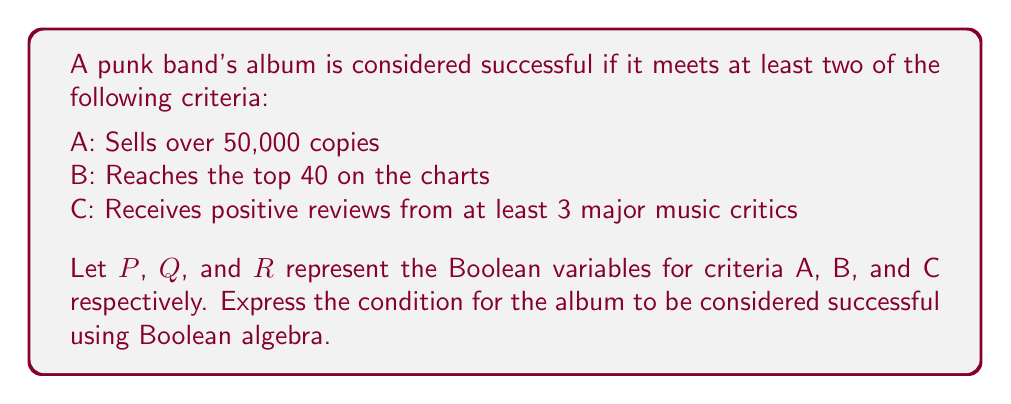Can you answer this question? To solve this problem, we need to express the condition "at least two of the criteria are met" using Boolean algebra. Let's approach this step-by-step:

1) We need to consider all possible combinations where at least two criteria are met:
   - A and B: $P \land Q$
   - A and C: $P \land R$
   - B and C: $Q \land R$
   - All three: $P \land Q \land R$ (this is already included in the above combinations)

2) The overall expression will be the OR (disjunction) of these combinations:
   $$(P \land Q) \lor (P \land R) \lor (Q \land R)$$

3) This expression can be simplified using the distributive law of Boolean algebra:
   $$(P \land Q) \lor (P \land R) \lor (Q \land R)$$
   $$= P \land (Q \lor R) \lor (Q \land R)$$

4) This is the simplified Boolean expression for the album's success condition.

As a label representative, you would use this expression to quickly determine if an album meets the success criteria by evaluating the truth values of P, Q, and R.
Answer: $P \land (Q \lor R) \lor (Q \land R)$ 